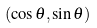<formula> <loc_0><loc_0><loc_500><loc_500>( \cos \theta , \sin \theta )</formula> 